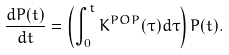Convert formula to latex. <formula><loc_0><loc_0><loc_500><loc_500>\frac { d P ( t ) } { d t } = \left ( \int _ { 0 } ^ { t } K ^ { P O P } ( \tau ) d \tau \right ) P ( t ) .</formula> 